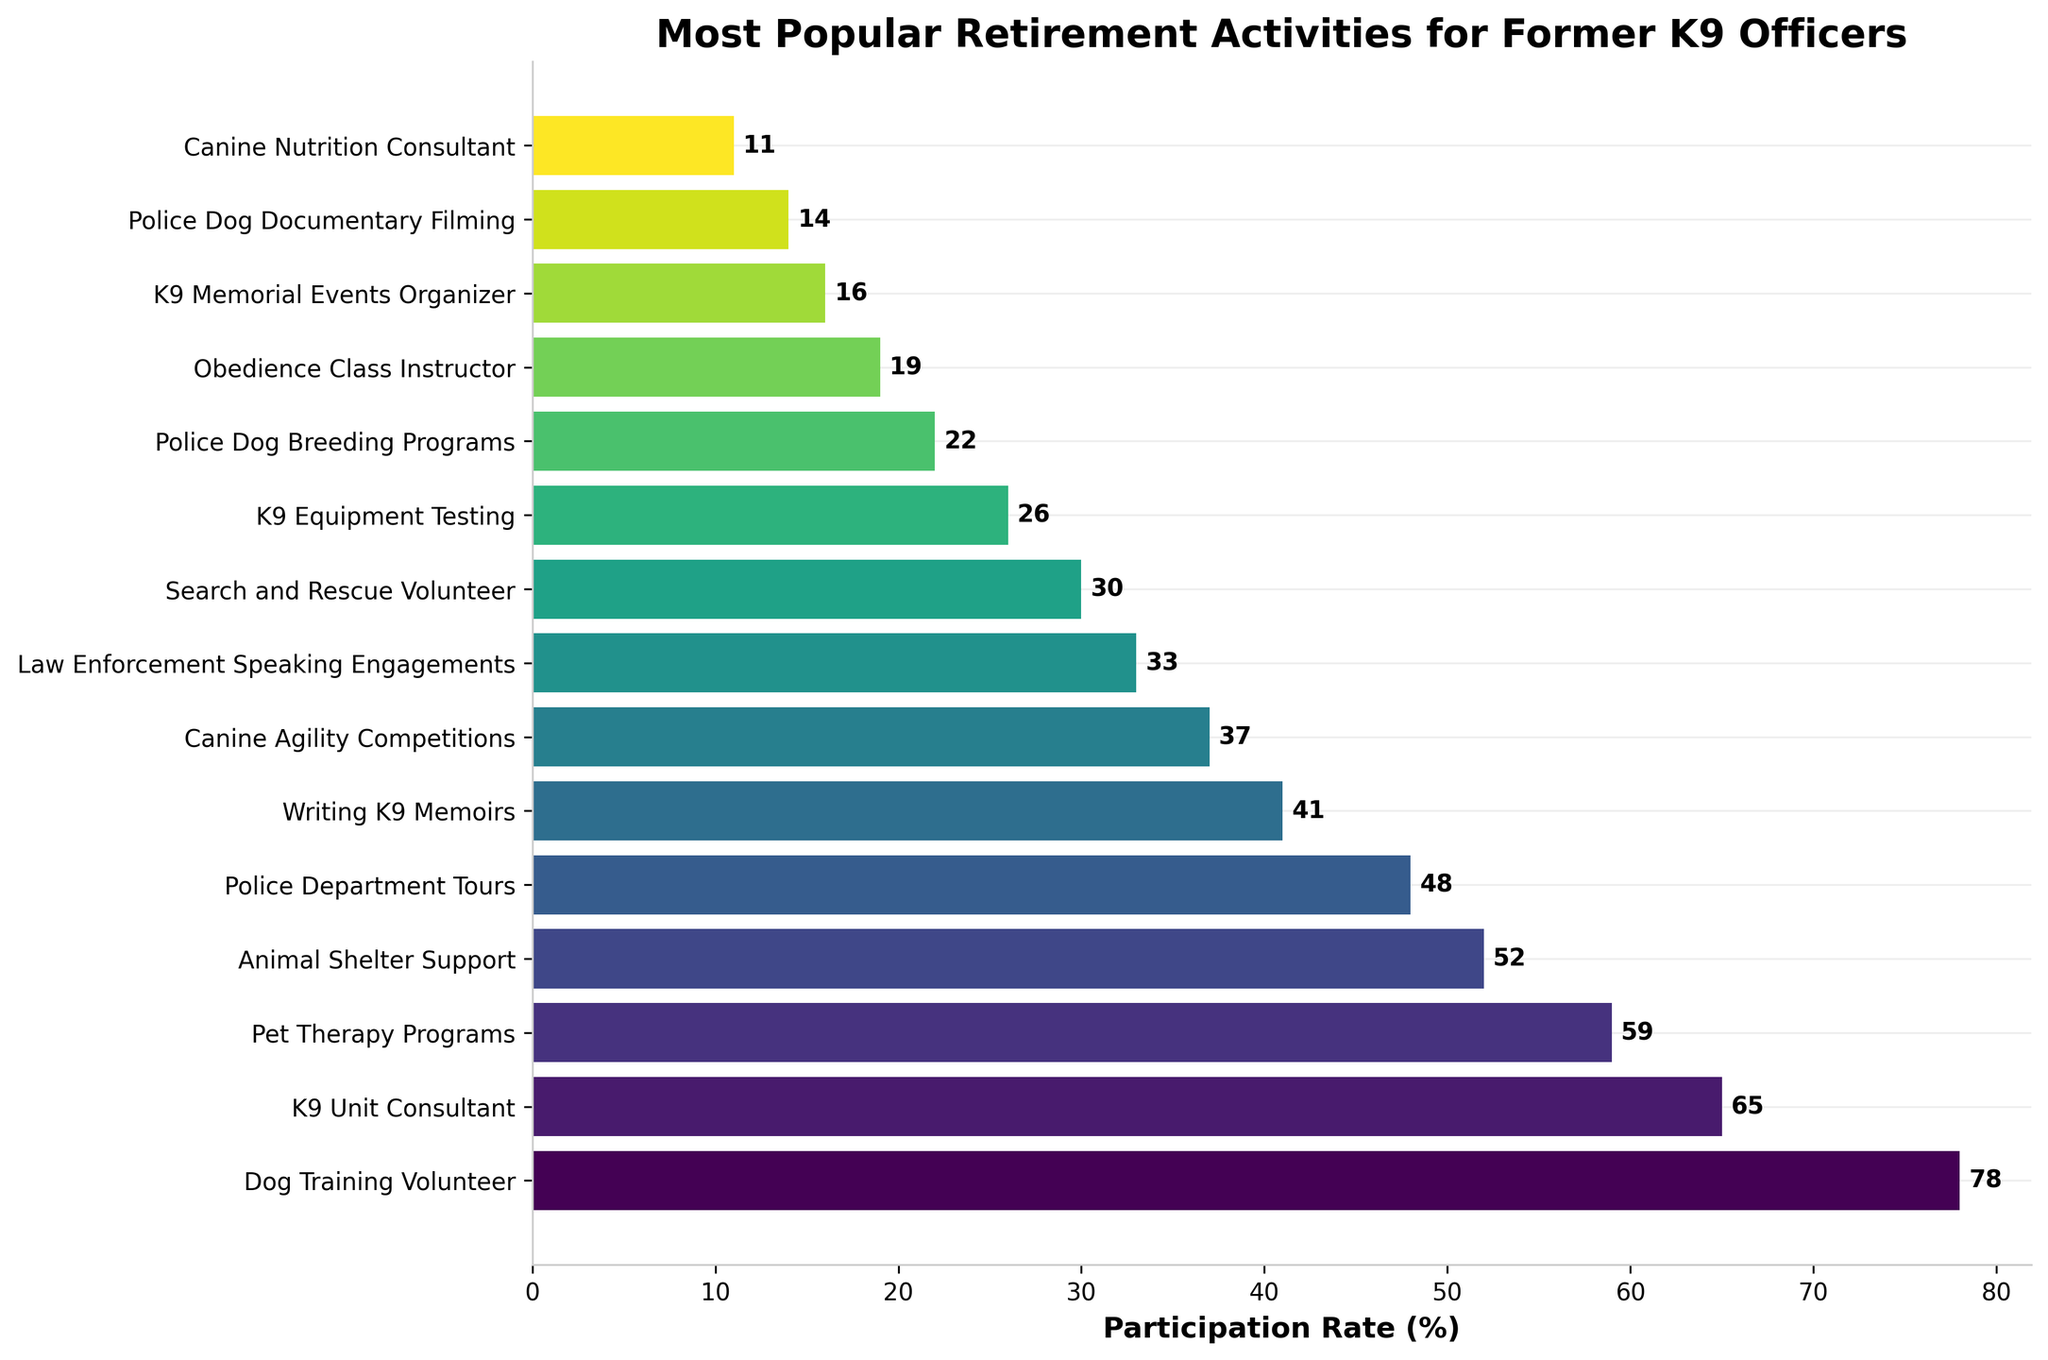Which activity has the highest participation rate among retired K9 officers? The bar corresponding to "Dog Training Volunteer" is the tallest, meaning it has the highest participation rate.
Answer: Dog Training Volunteer What is the participation rate for Police Dog Breeding Programs? Find the bar labeled "Police Dog Breeding Programs" and read the corresponding value, which is 22%.
Answer: 22% What is the total participation rate for the top three activities? Sum the participation rates for "Dog Training Volunteer," "K9 Unit Consultant," and "Pet Therapy Programs": 78% + 65% + 59% = 202%.
Answer: 202% Which two activities have the closest participation rates? "Animal Shelter Support" and "Police Department Tours" have close participation rates of 52% and 48%, respectively, making them the closest in value.
Answer: Animal Shelter Support and Police Department Tours How does the participation rate for Writing K9 Memoirs compare to K9 Equipment Testing? "Writing K9 Memoirs" (41%) is higher than "K9 Equipment Testing" (26%).
Answer: Writing K9 Memoirs is higher What is the average participation rate of all activities? Sum all the participation rates and divide by the number of activities. 78 + 65 + 59 + 52 + 48 + 41 + 37 + 33 + 30 + 26 + 22 + 19 + 16 + 14 + 11 = 551; there are 15 activities, so 551 / 15 = 36.73%.
Answer: 36.73% What is the median participation rate? The data points are ordered as: 11, 14, 16, 19, 22, 26, 30, 33, 37, 41, 48, 52, 59, 65, 78. The median is the middle value, so the 8th value: 33%.
Answer: 33% Which activity has the lowest participation rate? The shortest bar corresponds to "Canine Nutrition Consultant," which has the lowest participation rate of 11%.
Answer: Canine Nutrition Consultant How much higher is the participation rate for K9 Unit Consultant compared to Canine Agility Competitions? Subtract the participation rate of "Canine Agility Competitions" (37%) from "K9 Unit Consultant" (65%): 65% - 37% = 28%.
Answer: 28% Which activities have a participation rate over 50%? Identify activities with bars taller than the 50% mark: "Dog Training Volunteer" (78%), "K9 Unit Consultant" (65%), "Pet Therapy Programs" (59%), and "Animal Shelter Support" (52%).
Answer: Dog Training Volunteer, K9 Unit Consultant, Pet Therapy Programs, Animal Shelter Support 